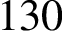Convert formula to latex. <formula><loc_0><loc_0><loc_500><loc_500>1 3 0</formula> 